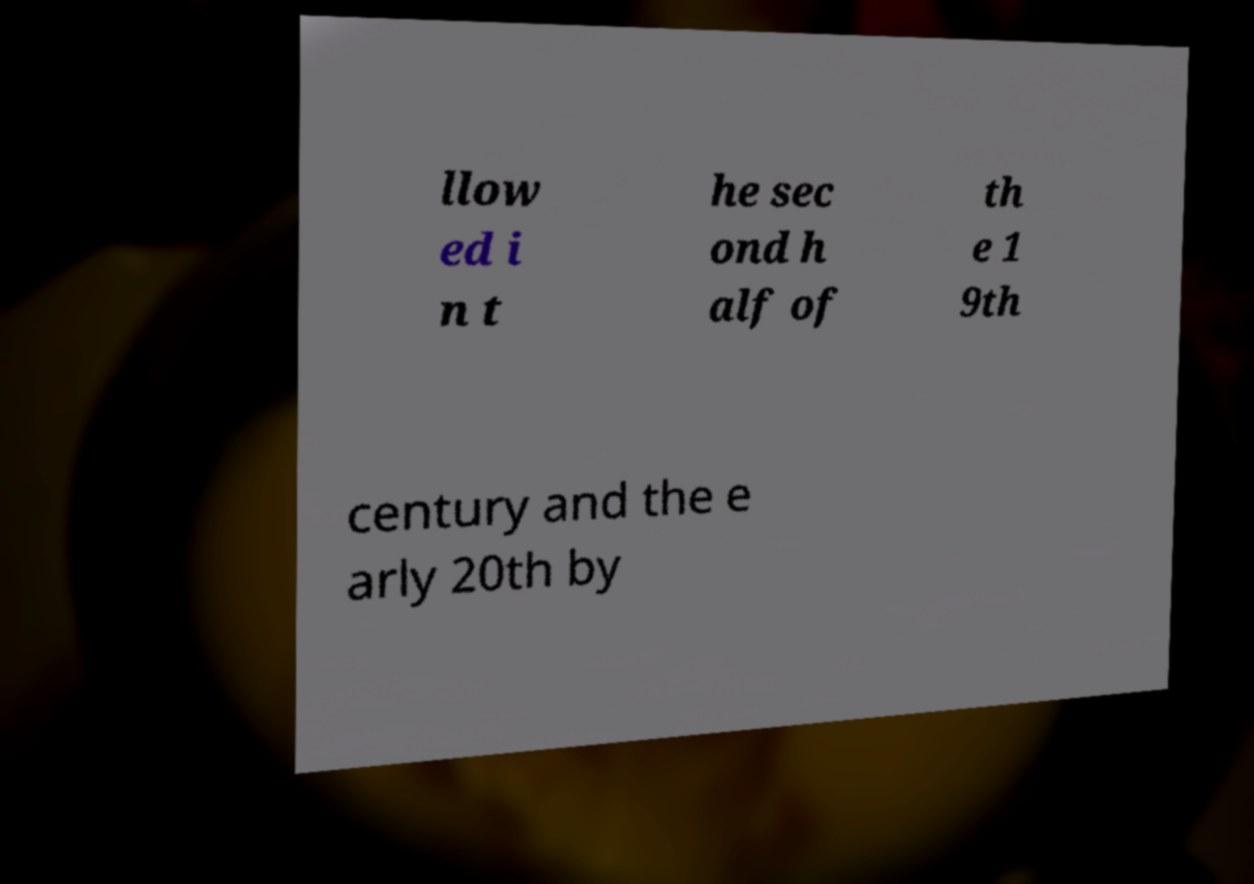Could you assist in decoding the text presented in this image and type it out clearly? llow ed i n t he sec ond h alf of th e 1 9th century and the e arly 20th by 